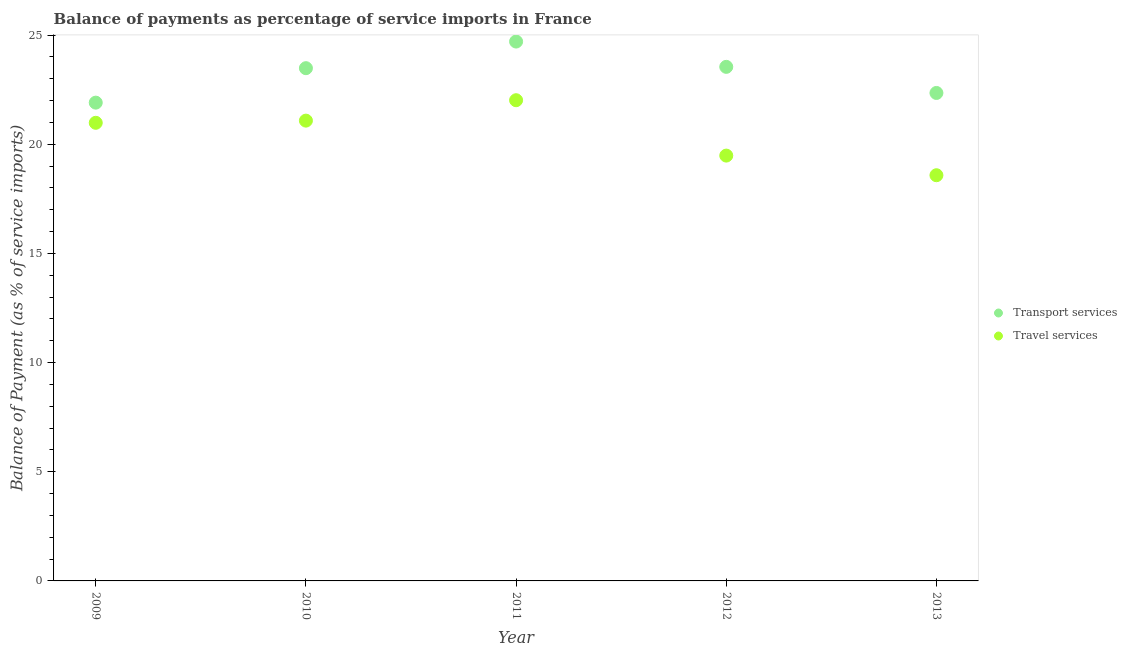How many different coloured dotlines are there?
Offer a very short reply. 2. Is the number of dotlines equal to the number of legend labels?
Provide a short and direct response. Yes. What is the balance of payments of travel services in 2012?
Provide a short and direct response. 19.48. Across all years, what is the maximum balance of payments of travel services?
Your answer should be very brief. 22.02. Across all years, what is the minimum balance of payments of transport services?
Provide a succinct answer. 21.91. In which year was the balance of payments of transport services minimum?
Ensure brevity in your answer.  2009. What is the total balance of payments of travel services in the graph?
Provide a short and direct response. 102.14. What is the difference between the balance of payments of travel services in 2011 and that in 2012?
Provide a succinct answer. 2.54. What is the difference between the balance of payments of travel services in 2010 and the balance of payments of transport services in 2013?
Offer a terse response. -1.27. What is the average balance of payments of travel services per year?
Give a very brief answer. 20.43. In the year 2012, what is the difference between the balance of payments of travel services and balance of payments of transport services?
Offer a terse response. -4.06. In how many years, is the balance of payments of travel services greater than 12 %?
Your answer should be very brief. 5. What is the ratio of the balance of payments of travel services in 2010 to that in 2013?
Keep it short and to the point. 1.13. Is the difference between the balance of payments of travel services in 2012 and 2013 greater than the difference between the balance of payments of transport services in 2012 and 2013?
Offer a terse response. No. What is the difference between the highest and the second highest balance of payments of transport services?
Give a very brief answer. 1.16. What is the difference between the highest and the lowest balance of payments of transport services?
Offer a terse response. 2.8. Is the balance of payments of transport services strictly greater than the balance of payments of travel services over the years?
Your answer should be very brief. Yes. Is the balance of payments of travel services strictly less than the balance of payments of transport services over the years?
Make the answer very short. Yes. What is the difference between two consecutive major ticks on the Y-axis?
Your response must be concise. 5. Does the graph contain any zero values?
Your answer should be very brief. No. Does the graph contain grids?
Keep it short and to the point. No. How are the legend labels stacked?
Make the answer very short. Vertical. What is the title of the graph?
Make the answer very short. Balance of payments as percentage of service imports in France. What is the label or title of the X-axis?
Ensure brevity in your answer.  Year. What is the label or title of the Y-axis?
Offer a very short reply. Balance of Payment (as % of service imports). What is the Balance of Payment (as % of service imports) of Transport services in 2009?
Provide a short and direct response. 21.91. What is the Balance of Payment (as % of service imports) of Travel services in 2009?
Make the answer very short. 20.98. What is the Balance of Payment (as % of service imports) of Transport services in 2010?
Your response must be concise. 23.48. What is the Balance of Payment (as % of service imports) of Travel services in 2010?
Your answer should be compact. 21.08. What is the Balance of Payment (as % of service imports) of Transport services in 2011?
Offer a terse response. 24.7. What is the Balance of Payment (as % of service imports) of Travel services in 2011?
Provide a short and direct response. 22.02. What is the Balance of Payment (as % of service imports) of Transport services in 2012?
Give a very brief answer. 23.54. What is the Balance of Payment (as % of service imports) in Travel services in 2012?
Offer a terse response. 19.48. What is the Balance of Payment (as % of service imports) in Transport services in 2013?
Provide a succinct answer. 22.35. What is the Balance of Payment (as % of service imports) of Travel services in 2013?
Ensure brevity in your answer.  18.58. Across all years, what is the maximum Balance of Payment (as % of service imports) of Transport services?
Make the answer very short. 24.7. Across all years, what is the maximum Balance of Payment (as % of service imports) of Travel services?
Your answer should be compact. 22.02. Across all years, what is the minimum Balance of Payment (as % of service imports) in Transport services?
Give a very brief answer. 21.91. Across all years, what is the minimum Balance of Payment (as % of service imports) in Travel services?
Offer a terse response. 18.58. What is the total Balance of Payment (as % of service imports) in Transport services in the graph?
Provide a succinct answer. 115.99. What is the total Balance of Payment (as % of service imports) of Travel services in the graph?
Ensure brevity in your answer.  102.14. What is the difference between the Balance of Payment (as % of service imports) in Transport services in 2009 and that in 2010?
Give a very brief answer. -1.58. What is the difference between the Balance of Payment (as % of service imports) in Travel services in 2009 and that in 2010?
Ensure brevity in your answer.  -0.1. What is the difference between the Balance of Payment (as % of service imports) of Transport services in 2009 and that in 2011?
Ensure brevity in your answer.  -2.8. What is the difference between the Balance of Payment (as % of service imports) of Travel services in 2009 and that in 2011?
Make the answer very short. -1.03. What is the difference between the Balance of Payment (as % of service imports) in Transport services in 2009 and that in 2012?
Keep it short and to the point. -1.64. What is the difference between the Balance of Payment (as % of service imports) in Travel services in 2009 and that in 2012?
Offer a very short reply. 1.5. What is the difference between the Balance of Payment (as % of service imports) of Transport services in 2009 and that in 2013?
Make the answer very short. -0.44. What is the difference between the Balance of Payment (as % of service imports) of Travel services in 2009 and that in 2013?
Offer a very short reply. 2.4. What is the difference between the Balance of Payment (as % of service imports) of Transport services in 2010 and that in 2011?
Provide a short and direct response. -1.22. What is the difference between the Balance of Payment (as % of service imports) of Travel services in 2010 and that in 2011?
Give a very brief answer. -0.93. What is the difference between the Balance of Payment (as % of service imports) of Transport services in 2010 and that in 2012?
Your answer should be very brief. -0.06. What is the difference between the Balance of Payment (as % of service imports) of Travel services in 2010 and that in 2012?
Offer a terse response. 1.6. What is the difference between the Balance of Payment (as % of service imports) of Transport services in 2010 and that in 2013?
Offer a terse response. 1.14. What is the difference between the Balance of Payment (as % of service imports) in Travel services in 2010 and that in 2013?
Provide a succinct answer. 2.5. What is the difference between the Balance of Payment (as % of service imports) in Transport services in 2011 and that in 2012?
Keep it short and to the point. 1.16. What is the difference between the Balance of Payment (as % of service imports) of Travel services in 2011 and that in 2012?
Provide a succinct answer. 2.54. What is the difference between the Balance of Payment (as % of service imports) of Transport services in 2011 and that in 2013?
Your response must be concise. 2.35. What is the difference between the Balance of Payment (as % of service imports) in Travel services in 2011 and that in 2013?
Your answer should be compact. 3.44. What is the difference between the Balance of Payment (as % of service imports) of Transport services in 2012 and that in 2013?
Keep it short and to the point. 1.2. What is the difference between the Balance of Payment (as % of service imports) in Travel services in 2012 and that in 2013?
Provide a short and direct response. 0.9. What is the difference between the Balance of Payment (as % of service imports) of Transport services in 2009 and the Balance of Payment (as % of service imports) of Travel services in 2010?
Your answer should be very brief. 0.82. What is the difference between the Balance of Payment (as % of service imports) in Transport services in 2009 and the Balance of Payment (as % of service imports) in Travel services in 2011?
Ensure brevity in your answer.  -0.11. What is the difference between the Balance of Payment (as % of service imports) in Transport services in 2009 and the Balance of Payment (as % of service imports) in Travel services in 2012?
Provide a short and direct response. 2.43. What is the difference between the Balance of Payment (as % of service imports) of Transport services in 2009 and the Balance of Payment (as % of service imports) of Travel services in 2013?
Your answer should be very brief. 3.32. What is the difference between the Balance of Payment (as % of service imports) of Transport services in 2010 and the Balance of Payment (as % of service imports) of Travel services in 2011?
Your response must be concise. 1.47. What is the difference between the Balance of Payment (as % of service imports) in Transport services in 2010 and the Balance of Payment (as % of service imports) in Travel services in 2012?
Make the answer very short. 4. What is the difference between the Balance of Payment (as % of service imports) of Transport services in 2010 and the Balance of Payment (as % of service imports) of Travel services in 2013?
Your answer should be compact. 4.9. What is the difference between the Balance of Payment (as % of service imports) in Transport services in 2011 and the Balance of Payment (as % of service imports) in Travel services in 2012?
Provide a short and direct response. 5.22. What is the difference between the Balance of Payment (as % of service imports) in Transport services in 2011 and the Balance of Payment (as % of service imports) in Travel services in 2013?
Ensure brevity in your answer.  6.12. What is the difference between the Balance of Payment (as % of service imports) of Transport services in 2012 and the Balance of Payment (as % of service imports) of Travel services in 2013?
Provide a short and direct response. 4.96. What is the average Balance of Payment (as % of service imports) of Transport services per year?
Provide a short and direct response. 23.2. What is the average Balance of Payment (as % of service imports) of Travel services per year?
Provide a succinct answer. 20.43. In the year 2009, what is the difference between the Balance of Payment (as % of service imports) of Transport services and Balance of Payment (as % of service imports) of Travel services?
Keep it short and to the point. 0.92. In the year 2010, what is the difference between the Balance of Payment (as % of service imports) of Transport services and Balance of Payment (as % of service imports) of Travel services?
Your answer should be very brief. 2.4. In the year 2011, what is the difference between the Balance of Payment (as % of service imports) of Transport services and Balance of Payment (as % of service imports) of Travel services?
Offer a very short reply. 2.69. In the year 2012, what is the difference between the Balance of Payment (as % of service imports) of Transport services and Balance of Payment (as % of service imports) of Travel services?
Keep it short and to the point. 4.06. In the year 2013, what is the difference between the Balance of Payment (as % of service imports) of Transport services and Balance of Payment (as % of service imports) of Travel services?
Make the answer very short. 3.77. What is the ratio of the Balance of Payment (as % of service imports) of Transport services in 2009 to that in 2010?
Your answer should be very brief. 0.93. What is the ratio of the Balance of Payment (as % of service imports) of Transport services in 2009 to that in 2011?
Offer a terse response. 0.89. What is the ratio of the Balance of Payment (as % of service imports) in Travel services in 2009 to that in 2011?
Offer a very short reply. 0.95. What is the ratio of the Balance of Payment (as % of service imports) of Transport services in 2009 to that in 2012?
Your answer should be compact. 0.93. What is the ratio of the Balance of Payment (as % of service imports) of Travel services in 2009 to that in 2012?
Make the answer very short. 1.08. What is the ratio of the Balance of Payment (as % of service imports) in Transport services in 2009 to that in 2013?
Ensure brevity in your answer.  0.98. What is the ratio of the Balance of Payment (as % of service imports) in Travel services in 2009 to that in 2013?
Provide a succinct answer. 1.13. What is the ratio of the Balance of Payment (as % of service imports) of Transport services in 2010 to that in 2011?
Ensure brevity in your answer.  0.95. What is the ratio of the Balance of Payment (as % of service imports) in Travel services in 2010 to that in 2011?
Keep it short and to the point. 0.96. What is the ratio of the Balance of Payment (as % of service imports) in Travel services in 2010 to that in 2012?
Make the answer very short. 1.08. What is the ratio of the Balance of Payment (as % of service imports) of Transport services in 2010 to that in 2013?
Give a very brief answer. 1.05. What is the ratio of the Balance of Payment (as % of service imports) in Travel services in 2010 to that in 2013?
Your answer should be very brief. 1.13. What is the ratio of the Balance of Payment (as % of service imports) in Transport services in 2011 to that in 2012?
Provide a short and direct response. 1.05. What is the ratio of the Balance of Payment (as % of service imports) of Travel services in 2011 to that in 2012?
Offer a terse response. 1.13. What is the ratio of the Balance of Payment (as % of service imports) of Transport services in 2011 to that in 2013?
Provide a short and direct response. 1.11. What is the ratio of the Balance of Payment (as % of service imports) of Travel services in 2011 to that in 2013?
Your answer should be compact. 1.18. What is the ratio of the Balance of Payment (as % of service imports) of Transport services in 2012 to that in 2013?
Make the answer very short. 1.05. What is the ratio of the Balance of Payment (as % of service imports) of Travel services in 2012 to that in 2013?
Ensure brevity in your answer.  1.05. What is the difference between the highest and the second highest Balance of Payment (as % of service imports) of Transport services?
Make the answer very short. 1.16. What is the difference between the highest and the second highest Balance of Payment (as % of service imports) of Travel services?
Provide a short and direct response. 0.93. What is the difference between the highest and the lowest Balance of Payment (as % of service imports) in Transport services?
Your answer should be compact. 2.8. What is the difference between the highest and the lowest Balance of Payment (as % of service imports) in Travel services?
Your response must be concise. 3.44. 